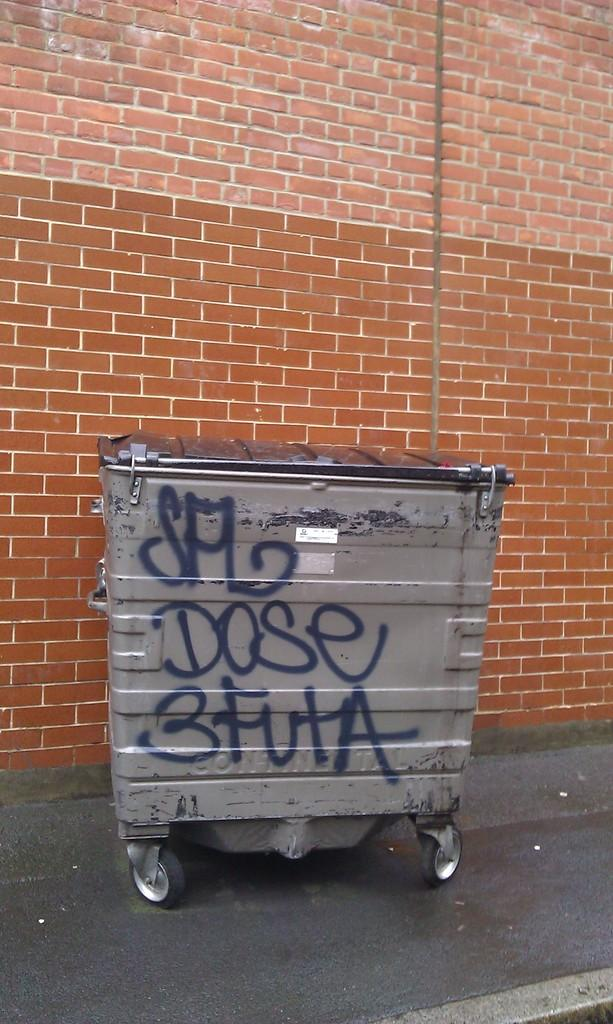Provide a one-sentence caption for the provided image. A dumpster with dose 3 futa graffiti sits next to a brick building. 